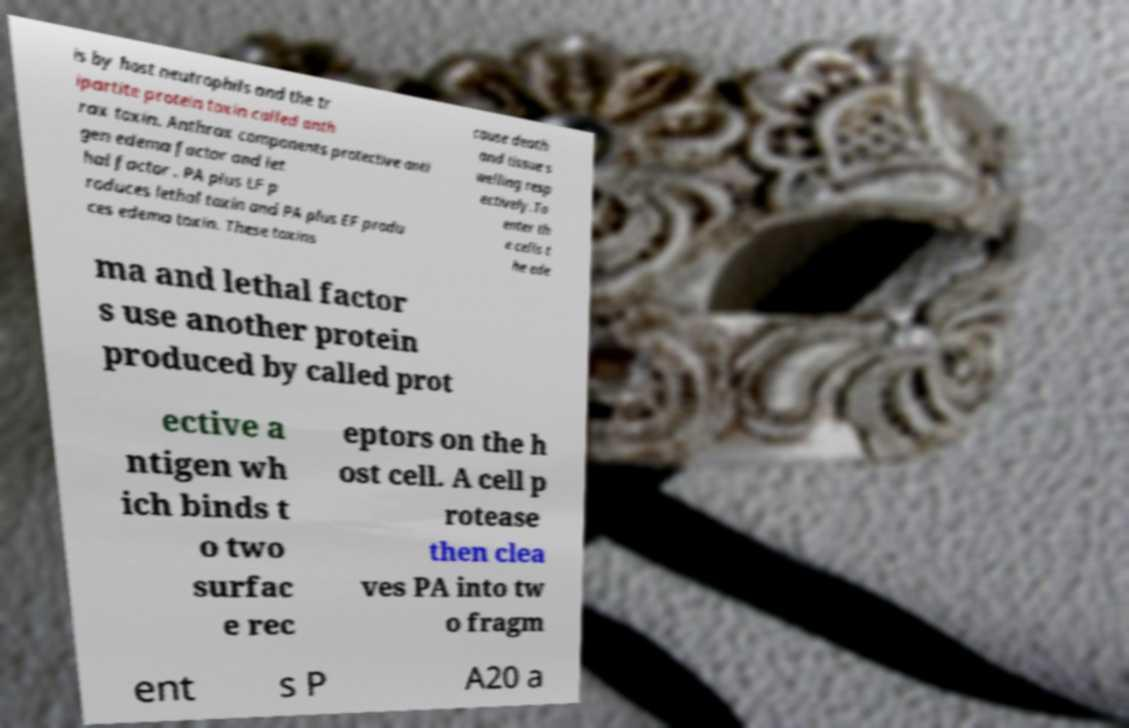Can you read and provide the text displayed in the image?This photo seems to have some interesting text. Can you extract and type it out for me? is by host neutrophils and the tr ipartite protein toxin called anth rax toxin. Anthrax components protective anti gen edema factor and let hal factor . PA plus LF p roduces lethal toxin and PA plus EF produ ces edema toxin. These toxins cause death and tissue s welling resp ectively.To enter th e cells t he ede ma and lethal factor s use another protein produced by called prot ective a ntigen wh ich binds t o two surfac e rec eptors on the h ost cell. A cell p rotease then clea ves PA into tw o fragm ent s P A20 a 